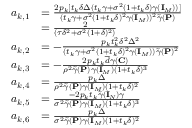Convert formula to latex. <formula><loc_0><loc_0><loc_500><loc_500>\begin{array} { r l } { a _ { k , 1 } } & { = \frac { 2 p _ { k } [ t _ { k } \delta \Delta ( t _ { k } \gamma + \sigma ^ { 2 } ( 1 + t _ { k } \delta ) \gamma ( { I } _ { M } ) ) ] } { ( t _ { k } \gamma + \sigma ^ { 2 } ( 1 + t _ { k } \delta ) ^ { 2 } \gamma ( { I } _ { M } ) ) ^ { 2 } \widetilde { \gamma } ( { P } ) } } \\ & { = \frac { 2 } { ( \tau \delta ^ { 2 } + \sigma ^ { 2 } ( 1 + \delta ) ^ { 2 } ) } } \\ { a _ { k , 2 } } & { = - \frac { p _ { k } t _ { k } ^ { 2 } \delta ^ { 2 } \Delta ^ { 2 } } { ( t _ { k } \gamma + \sigma ^ { 2 } ( 1 + t _ { k } \delta ) ^ { 2 } \gamma ( { I } _ { M } ) ) \widetilde { \gamma } ( { P } ) ^ { 2 } } } \\ { a _ { k , 3 } } & { = - \frac { 2 p _ { k } t _ { k } \overline { d } \gamma ( { C } ) } { \rho ^ { 2 } \widetilde { \gamma } ( { P } ) \gamma ( { I } _ { M } ) ( 1 + t _ { k } \delta ) ^ { 3 } } } \\ { a _ { k , 4 } } & { = \frac { p _ { k } \Delta } { \rho ^ { 2 } \widetilde { \gamma } ( { P } ) \gamma ( { I } _ { M } ) ( 1 + t _ { k } \delta ) ^ { 2 } } } \\ { a _ { k , 5 } } & { = \frac { - 2 p _ { k } t _ { k } \widetilde { \gamma } ( { I } _ { N } ) \gamma } { \sigma ^ { 2 } \widetilde { \gamma } ( { P } ) \gamma ( { I } _ { M } ) ( 1 + t _ { k } \delta ) ^ { 3 } } } \\ { a _ { k , 6 } } & { = \frac { p _ { k } \Delta } { \sigma ^ { 2 } \widetilde { \gamma } ( { P } ) \gamma ( { I } _ { M } ) ( 1 + t _ { k } \delta ) ^ { 2 } } } \end{array}</formula> 